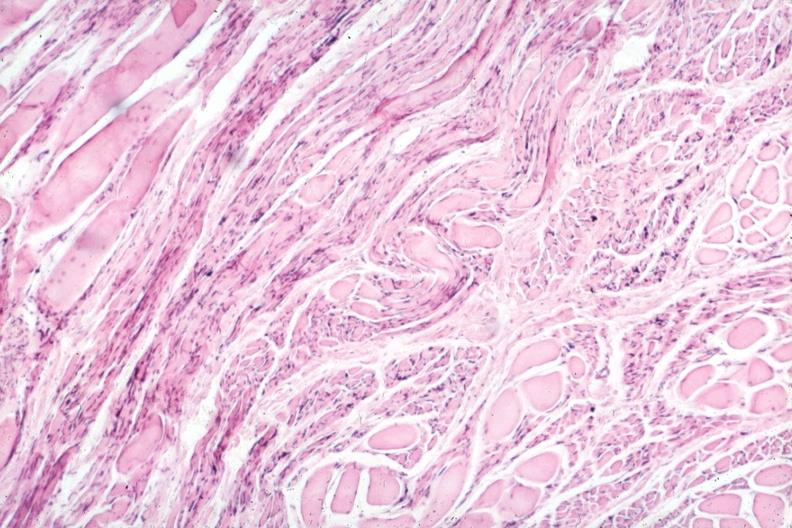what is present?
Answer the question using a single word or phrase. Soft tissue 